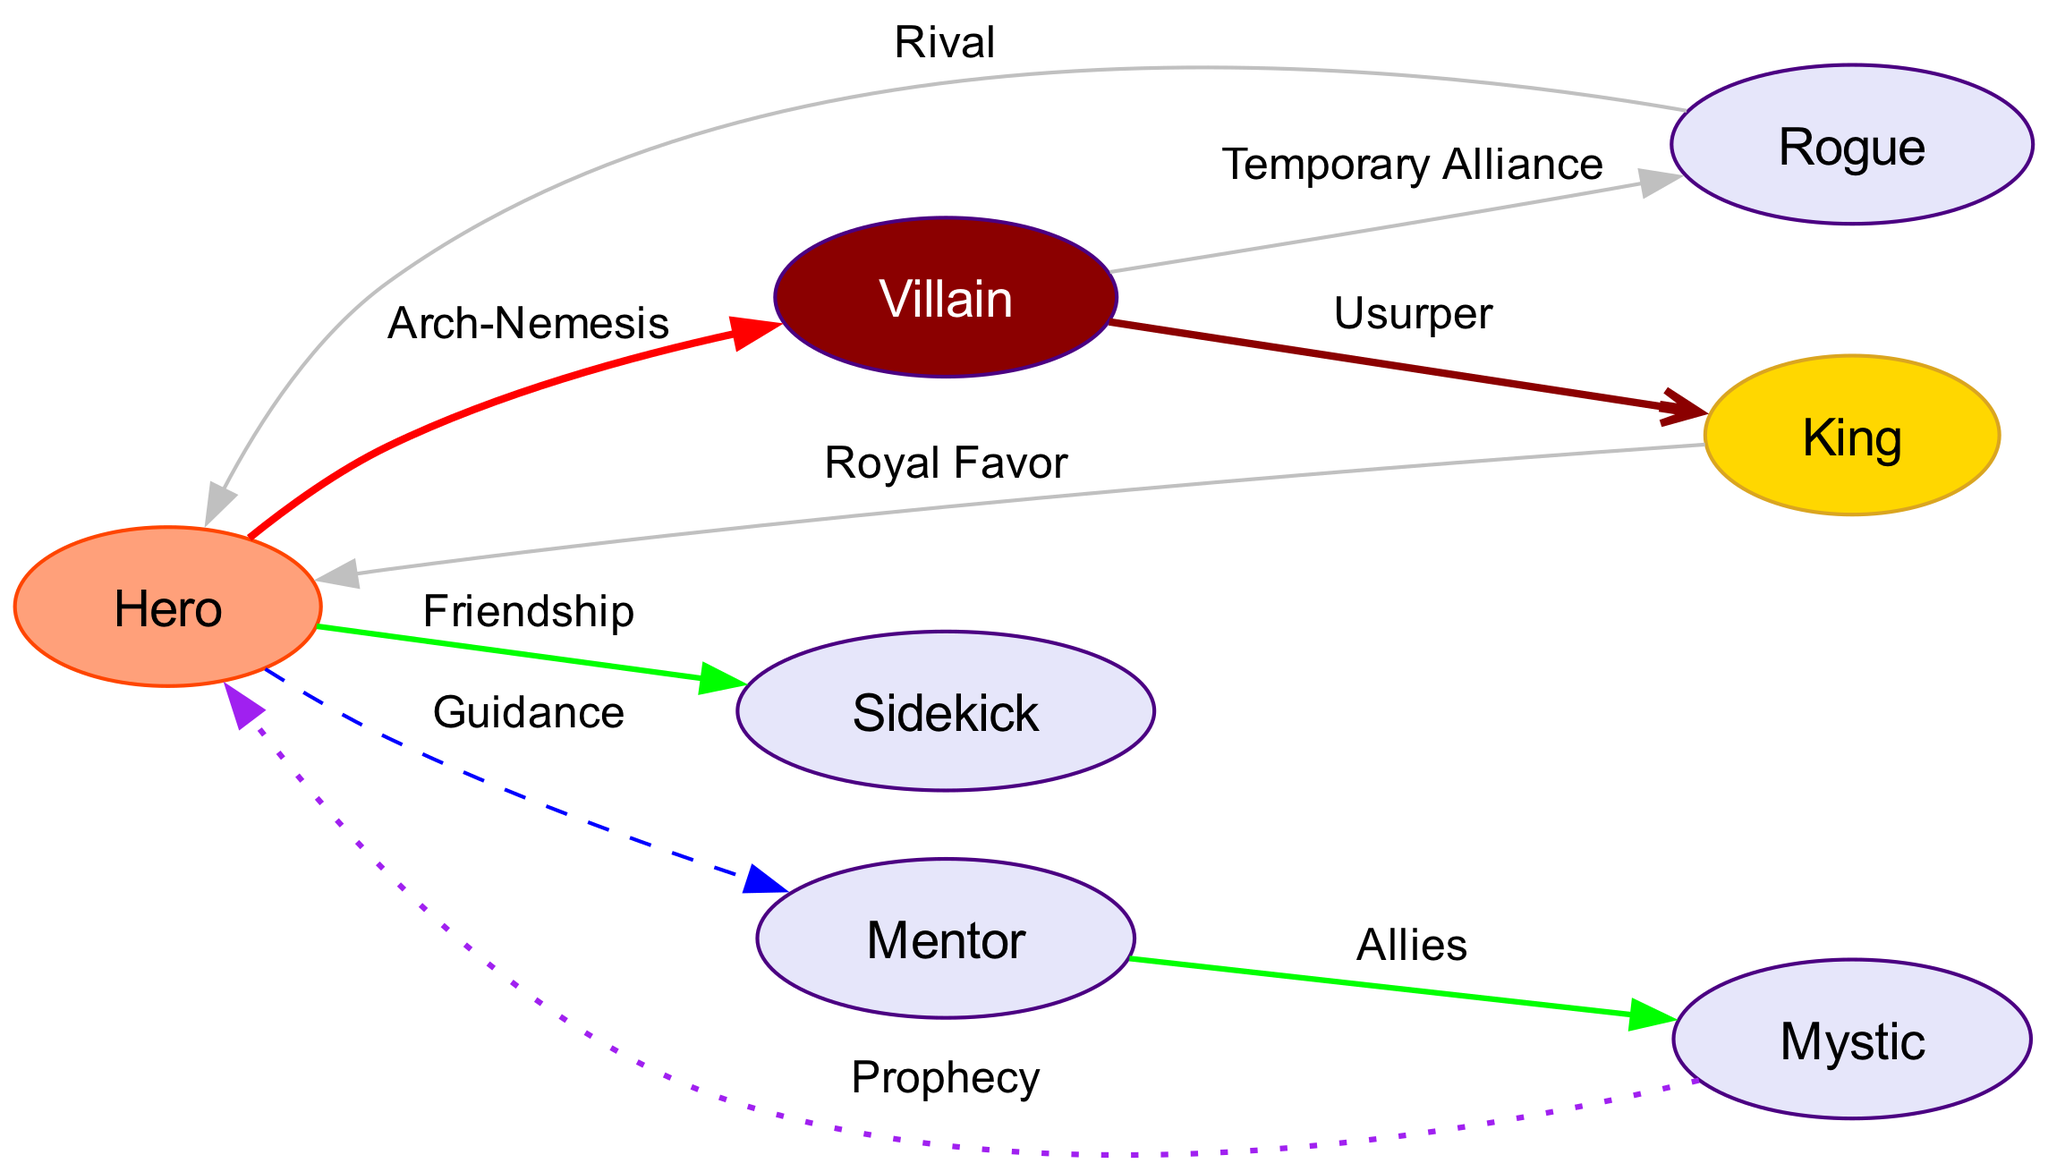What is the main relationship between the Hero and the Villain? According to the edges in the diagram, the Hero has a relationship labeled "Arch-Nemesis" with the Villain, indicating their primary conflict.
Answer: Arch-Nemesis How many characters are allies of the Hero? The diagram shows that the Hero has a direct relationship with both the Mentor (Guidance) and the Mystic (Prophecy). Additionally, the Mentor is allied with the Mystic. Thus, the total number of allies for the Hero, based on direct or indirect connecting edges, is three.
Answer: 3 What type of relationship exists between the Mentor and the Mystic? The edge between the Mentor and the Mystic is labeled "Allies," indicating that they share a cooperative relationship.
Answer: Allies Who does the King have a Royal Favor relationship with? The edge between the King and the Hero is marked as "Royal Favor," indicating that the King shows favor towards the Hero.
Answer: Hero What is the nature of the relationship between the Villain and the Rogue? The edge between the Villain and the Rogue is labeled "Temporary Alliance," suggesting that they cooperate for a brief period, although this may not indicate a long-term bond.
Answer: Temporary Alliance Which character is an Usurper? The diagram shows the Villain has a relationship labeled "Usurper" in connection to the King, indicating that the Villain is attempting to seize power from the King.
Answer: Villain Which character has a Rival relationship with the Hero? The Rogue has a direct relationship with the Hero labeled "Rival," meaning that they are competitors or adversaries.
Answer: Rogue How many total edges are in the diagram? By counting the edges provided in the data, there are a total of eight relationships connecting the characters in the diagram.
Answer: 8 Which character is connected to the Hero through Prophecy? The edge between the Mystic and the Hero is labeled "Prophecy," indicating that the Mystic foretells something related to the Hero's journey.
Answer: Mystic 